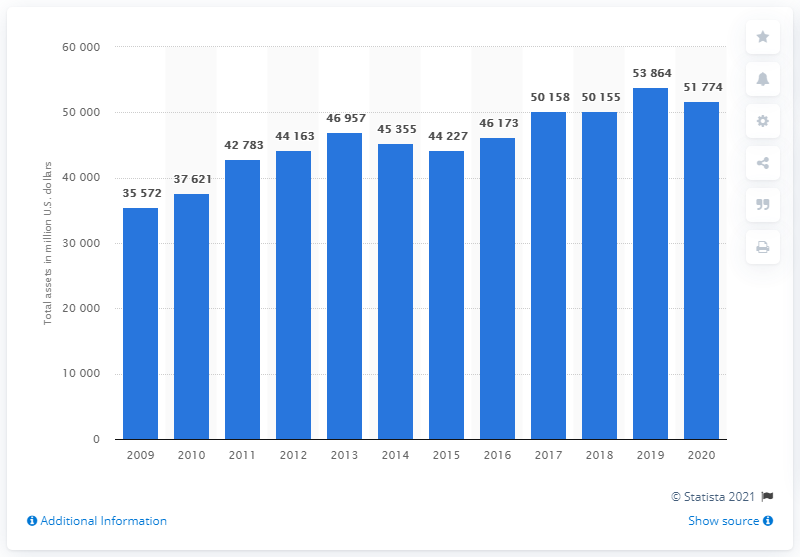Identify some key points in this picture. Valero Energy Corporation had a total assets value of approximately 51,774 as of 2020. Valero Energy Corporation's assets decreased by 51,774 from the previous year. 